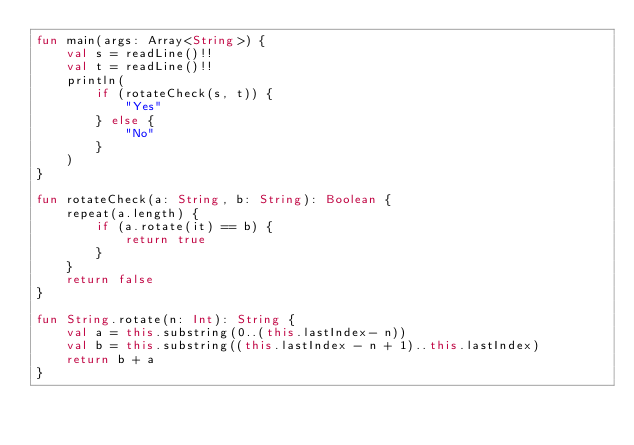Convert code to text. <code><loc_0><loc_0><loc_500><loc_500><_Kotlin_>fun main(args: Array<String>) {
    val s = readLine()!!
    val t = readLine()!!
    println(
        if (rotateCheck(s, t)) {
            "Yes"
        } else {
            "No"
        }
    )
}

fun rotateCheck(a: String, b: String): Boolean {
    repeat(a.length) {
        if (a.rotate(it) == b) {
            return true
        }
    }
    return false
}

fun String.rotate(n: Int): String {
    val a = this.substring(0..(this.lastIndex- n))
    val b = this.substring((this.lastIndex - n + 1)..this.lastIndex)
    return b + a
}
</code> 